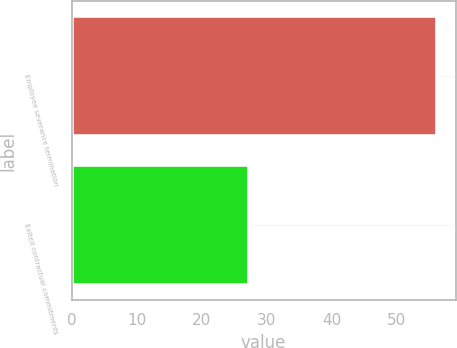Convert chart to OTSL. <chart><loc_0><loc_0><loc_500><loc_500><bar_chart><fcel>Employee severance termination<fcel>Exited contractual commitments<nl><fcel>56.2<fcel>27.3<nl></chart> 